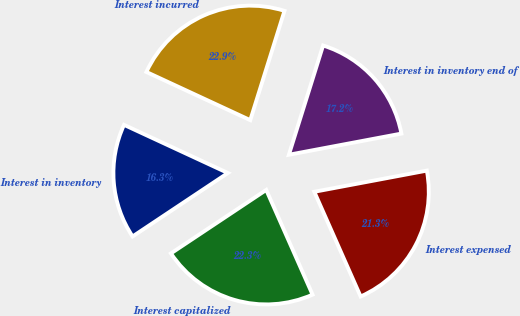Convert chart to OTSL. <chart><loc_0><loc_0><loc_500><loc_500><pie_chart><fcel>Interest in inventory<fcel>Interest capitalized<fcel>Interest expensed<fcel>Interest in inventory end of<fcel>Interest incurred<nl><fcel>16.26%<fcel>22.28%<fcel>21.33%<fcel>17.21%<fcel>22.92%<nl></chart> 